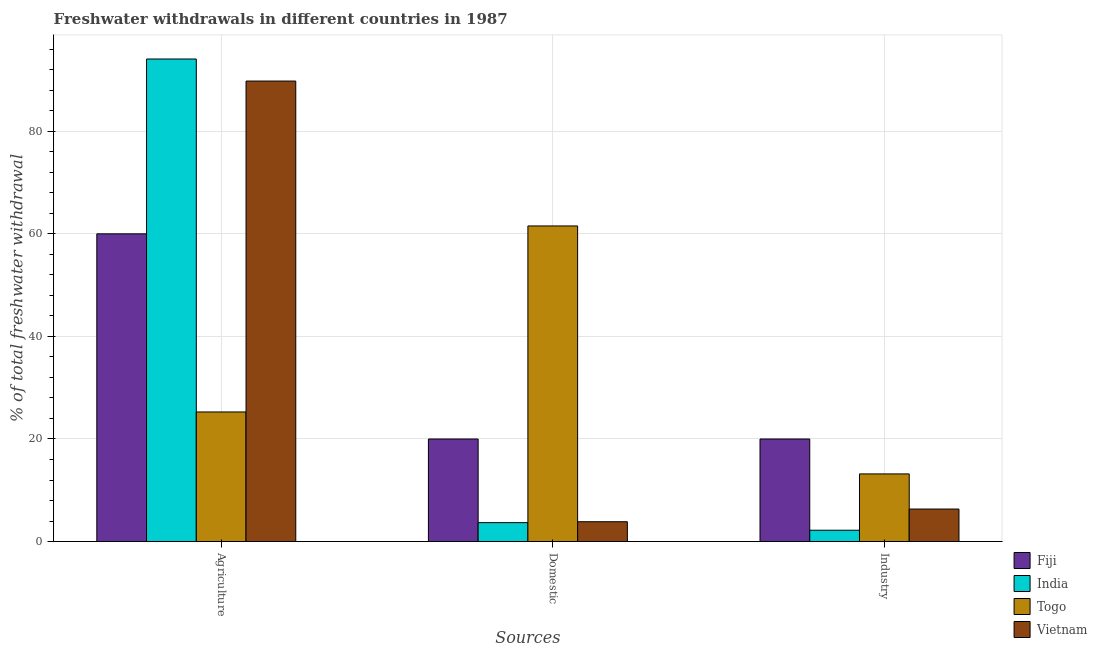How many different coloured bars are there?
Provide a short and direct response. 4. How many groups of bars are there?
Offer a very short reply. 3. How many bars are there on the 2nd tick from the left?
Provide a succinct answer. 4. What is the label of the 1st group of bars from the left?
Make the answer very short. Agriculture. What is the percentage of freshwater withdrawal for domestic purposes in Togo?
Offer a very short reply. 61.54. Across all countries, what is the minimum percentage of freshwater withdrawal for agriculture?
Your response must be concise. 25.27. In which country was the percentage of freshwater withdrawal for domestic purposes maximum?
Your answer should be compact. Togo. In which country was the percentage of freshwater withdrawal for industry minimum?
Offer a terse response. India. What is the total percentage of freshwater withdrawal for industry in the graph?
Offer a very short reply. 41.74. What is the difference between the percentage of freshwater withdrawal for industry in India and that in Fiji?
Provide a succinct answer. -17.79. What is the difference between the percentage of freshwater withdrawal for agriculture in Vietnam and the percentage of freshwater withdrawal for industry in Togo?
Offer a terse response. 76.6. What is the average percentage of freshwater withdrawal for industry per country?
Your answer should be very brief. 10.44. What is the difference between the percentage of freshwater withdrawal for agriculture and percentage of freshwater withdrawal for domestic purposes in Fiji?
Offer a terse response. 40. What is the ratio of the percentage of freshwater withdrawal for industry in Togo to that in Vietnam?
Give a very brief answer. 2.08. Is the difference between the percentage of freshwater withdrawal for agriculture in Vietnam and Fiji greater than the difference between the percentage of freshwater withdrawal for domestic purposes in Vietnam and Fiji?
Give a very brief answer. Yes. What is the difference between the highest and the second highest percentage of freshwater withdrawal for domestic purposes?
Give a very brief answer. 41.54. What is the difference between the highest and the lowest percentage of freshwater withdrawal for domestic purposes?
Your answer should be compact. 57.85. In how many countries, is the percentage of freshwater withdrawal for agriculture greater than the average percentage of freshwater withdrawal for agriculture taken over all countries?
Keep it short and to the point. 2. Is the sum of the percentage of freshwater withdrawal for industry in Togo and Fiji greater than the maximum percentage of freshwater withdrawal for domestic purposes across all countries?
Keep it short and to the point. No. What does the 1st bar from the left in Domestic represents?
Offer a terse response. Fiji. What does the 4th bar from the right in Domestic represents?
Keep it short and to the point. Fiji. How many countries are there in the graph?
Provide a short and direct response. 4. What is the difference between two consecutive major ticks on the Y-axis?
Keep it short and to the point. 20. Are the values on the major ticks of Y-axis written in scientific E-notation?
Ensure brevity in your answer.  No. Does the graph contain any zero values?
Provide a short and direct response. No. Does the graph contain grids?
Ensure brevity in your answer.  Yes. What is the title of the graph?
Ensure brevity in your answer.  Freshwater withdrawals in different countries in 1987. What is the label or title of the X-axis?
Provide a short and direct response. Sources. What is the label or title of the Y-axis?
Provide a short and direct response. % of total freshwater withdrawal. What is the % of total freshwater withdrawal of Fiji in Agriculture?
Your answer should be compact. 60. What is the % of total freshwater withdrawal of India in Agriculture?
Make the answer very short. 94.09. What is the % of total freshwater withdrawal in Togo in Agriculture?
Offer a terse response. 25.27. What is the % of total freshwater withdrawal of Vietnam in Agriculture?
Your response must be concise. 89.79. What is the % of total freshwater withdrawal in Fiji in Domestic?
Offer a very short reply. 20. What is the % of total freshwater withdrawal of India in Domestic?
Offer a very short reply. 3.69. What is the % of total freshwater withdrawal of Togo in Domestic?
Keep it short and to the point. 61.54. What is the % of total freshwater withdrawal of Vietnam in Domestic?
Offer a very short reply. 3.87. What is the % of total freshwater withdrawal in Fiji in Industry?
Make the answer very short. 20. What is the % of total freshwater withdrawal of India in Industry?
Ensure brevity in your answer.  2.21. What is the % of total freshwater withdrawal of Togo in Industry?
Your answer should be very brief. 13.19. What is the % of total freshwater withdrawal of Vietnam in Industry?
Provide a succinct answer. 6.34. Across all Sources, what is the maximum % of total freshwater withdrawal of India?
Ensure brevity in your answer.  94.09. Across all Sources, what is the maximum % of total freshwater withdrawal in Togo?
Offer a terse response. 61.54. Across all Sources, what is the maximum % of total freshwater withdrawal of Vietnam?
Provide a short and direct response. 89.79. Across all Sources, what is the minimum % of total freshwater withdrawal in India?
Give a very brief answer. 2.21. Across all Sources, what is the minimum % of total freshwater withdrawal in Togo?
Offer a very short reply. 13.19. Across all Sources, what is the minimum % of total freshwater withdrawal in Vietnam?
Your answer should be compact. 3.87. What is the total % of total freshwater withdrawal of India in the graph?
Give a very brief answer. 99.99. What is the total % of total freshwater withdrawal in Togo in the graph?
Make the answer very short. 100. What is the total % of total freshwater withdrawal of Vietnam in the graph?
Provide a short and direct response. 100. What is the difference between the % of total freshwater withdrawal of India in Agriculture and that in Domestic?
Offer a very short reply. 90.4. What is the difference between the % of total freshwater withdrawal in Togo in Agriculture and that in Domestic?
Provide a succinct answer. -36.27. What is the difference between the % of total freshwater withdrawal in Vietnam in Agriculture and that in Domestic?
Provide a short and direct response. 85.92. What is the difference between the % of total freshwater withdrawal in India in Agriculture and that in Industry?
Keep it short and to the point. 91.88. What is the difference between the % of total freshwater withdrawal in Togo in Agriculture and that in Industry?
Your answer should be very brief. 12.08. What is the difference between the % of total freshwater withdrawal in Vietnam in Agriculture and that in Industry?
Provide a short and direct response. 83.45. What is the difference between the % of total freshwater withdrawal of Fiji in Domestic and that in Industry?
Your answer should be very brief. 0. What is the difference between the % of total freshwater withdrawal in India in Domestic and that in Industry?
Offer a terse response. 1.48. What is the difference between the % of total freshwater withdrawal of Togo in Domestic and that in Industry?
Your answer should be compact. 48.35. What is the difference between the % of total freshwater withdrawal in Vietnam in Domestic and that in Industry?
Ensure brevity in your answer.  -2.47. What is the difference between the % of total freshwater withdrawal in Fiji in Agriculture and the % of total freshwater withdrawal in India in Domestic?
Make the answer very short. 56.31. What is the difference between the % of total freshwater withdrawal of Fiji in Agriculture and the % of total freshwater withdrawal of Togo in Domestic?
Your answer should be very brief. -1.54. What is the difference between the % of total freshwater withdrawal of Fiji in Agriculture and the % of total freshwater withdrawal of Vietnam in Domestic?
Offer a very short reply. 56.13. What is the difference between the % of total freshwater withdrawal of India in Agriculture and the % of total freshwater withdrawal of Togo in Domestic?
Give a very brief answer. 32.55. What is the difference between the % of total freshwater withdrawal in India in Agriculture and the % of total freshwater withdrawal in Vietnam in Domestic?
Keep it short and to the point. 90.22. What is the difference between the % of total freshwater withdrawal of Togo in Agriculture and the % of total freshwater withdrawal of Vietnam in Domestic?
Provide a short and direct response. 21.4. What is the difference between the % of total freshwater withdrawal in Fiji in Agriculture and the % of total freshwater withdrawal in India in Industry?
Make the answer very short. 57.79. What is the difference between the % of total freshwater withdrawal of Fiji in Agriculture and the % of total freshwater withdrawal of Togo in Industry?
Offer a very short reply. 46.81. What is the difference between the % of total freshwater withdrawal of Fiji in Agriculture and the % of total freshwater withdrawal of Vietnam in Industry?
Offer a very short reply. 53.66. What is the difference between the % of total freshwater withdrawal in India in Agriculture and the % of total freshwater withdrawal in Togo in Industry?
Keep it short and to the point. 80.9. What is the difference between the % of total freshwater withdrawal in India in Agriculture and the % of total freshwater withdrawal in Vietnam in Industry?
Ensure brevity in your answer.  87.75. What is the difference between the % of total freshwater withdrawal in Togo in Agriculture and the % of total freshwater withdrawal in Vietnam in Industry?
Your answer should be compact. 18.93. What is the difference between the % of total freshwater withdrawal in Fiji in Domestic and the % of total freshwater withdrawal in India in Industry?
Offer a terse response. 17.79. What is the difference between the % of total freshwater withdrawal in Fiji in Domestic and the % of total freshwater withdrawal in Togo in Industry?
Your answer should be compact. 6.81. What is the difference between the % of total freshwater withdrawal in Fiji in Domestic and the % of total freshwater withdrawal in Vietnam in Industry?
Offer a very short reply. 13.66. What is the difference between the % of total freshwater withdrawal in India in Domestic and the % of total freshwater withdrawal in Togo in Industry?
Your answer should be very brief. -9.5. What is the difference between the % of total freshwater withdrawal of India in Domestic and the % of total freshwater withdrawal of Vietnam in Industry?
Your answer should be very brief. -2.65. What is the difference between the % of total freshwater withdrawal in Togo in Domestic and the % of total freshwater withdrawal in Vietnam in Industry?
Your answer should be compact. 55.2. What is the average % of total freshwater withdrawal in Fiji per Sources?
Provide a succinct answer. 33.33. What is the average % of total freshwater withdrawal in India per Sources?
Offer a very short reply. 33.33. What is the average % of total freshwater withdrawal in Togo per Sources?
Ensure brevity in your answer.  33.33. What is the average % of total freshwater withdrawal of Vietnam per Sources?
Offer a very short reply. 33.33. What is the difference between the % of total freshwater withdrawal in Fiji and % of total freshwater withdrawal in India in Agriculture?
Give a very brief answer. -34.09. What is the difference between the % of total freshwater withdrawal of Fiji and % of total freshwater withdrawal of Togo in Agriculture?
Your response must be concise. 34.73. What is the difference between the % of total freshwater withdrawal of Fiji and % of total freshwater withdrawal of Vietnam in Agriculture?
Make the answer very short. -29.79. What is the difference between the % of total freshwater withdrawal in India and % of total freshwater withdrawal in Togo in Agriculture?
Your response must be concise. 68.82. What is the difference between the % of total freshwater withdrawal in India and % of total freshwater withdrawal in Vietnam in Agriculture?
Give a very brief answer. 4.3. What is the difference between the % of total freshwater withdrawal of Togo and % of total freshwater withdrawal of Vietnam in Agriculture?
Provide a short and direct response. -64.52. What is the difference between the % of total freshwater withdrawal in Fiji and % of total freshwater withdrawal in India in Domestic?
Offer a terse response. 16.31. What is the difference between the % of total freshwater withdrawal in Fiji and % of total freshwater withdrawal in Togo in Domestic?
Make the answer very short. -41.54. What is the difference between the % of total freshwater withdrawal of Fiji and % of total freshwater withdrawal of Vietnam in Domestic?
Your answer should be compact. 16.13. What is the difference between the % of total freshwater withdrawal of India and % of total freshwater withdrawal of Togo in Domestic?
Offer a very short reply. -57.85. What is the difference between the % of total freshwater withdrawal of India and % of total freshwater withdrawal of Vietnam in Domestic?
Keep it short and to the point. -0.17. What is the difference between the % of total freshwater withdrawal in Togo and % of total freshwater withdrawal in Vietnam in Domestic?
Offer a very short reply. 57.67. What is the difference between the % of total freshwater withdrawal of Fiji and % of total freshwater withdrawal of India in Industry?
Offer a terse response. 17.79. What is the difference between the % of total freshwater withdrawal of Fiji and % of total freshwater withdrawal of Togo in Industry?
Ensure brevity in your answer.  6.81. What is the difference between the % of total freshwater withdrawal of Fiji and % of total freshwater withdrawal of Vietnam in Industry?
Make the answer very short. 13.66. What is the difference between the % of total freshwater withdrawal in India and % of total freshwater withdrawal in Togo in Industry?
Offer a terse response. -10.98. What is the difference between the % of total freshwater withdrawal of India and % of total freshwater withdrawal of Vietnam in Industry?
Your response must be concise. -4.13. What is the difference between the % of total freshwater withdrawal of Togo and % of total freshwater withdrawal of Vietnam in Industry?
Provide a succinct answer. 6.85. What is the ratio of the % of total freshwater withdrawal of India in Agriculture to that in Domestic?
Your answer should be very brief. 25.49. What is the ratio of the % of total freshwater withdrawal in Togo in Agriculture to that in Domestic?
Provide a short and direct response. 0.41. What is the ratio of the % of total freshwater withdrawal in Vietnam in Agriculture to that in Domestic?
Your answer should be very brief. 23.23. What is the ratio of the % of total freshwater withdrawal of Fiji in Agriculture to that in Industry?
Offer a terse response. 3. What is the ratio of the % of total freshwater withdrawal in India in Agriculture to that in Industry?
Your answer should be compact. 42.56. What is the ratio of the % of total freshwater withdrawal in Togo in Agriculture to that in Industry?
Make the answer very short. 1.92. What is the ratio of the % of total freshwater withdrawal of Vietnam in Agriculture to that in Industry?
Offer a terse response. 14.16. What is the ratio of the % of total freshwater withdrawal in Fiji in Domestic to that in Industry?
Ensure brevity in your answer.  1. What is the ratio of the % of total freshwater withdrawal of India in Domestic to that in Industry?
Provide a succinct answer. 1.67. What is the ratio of the % of total freshwater withdrawal of Togo in Domestic to that in Industry?
Provide a succinct answer. 4.67. What is the ratio of the % of total freshwater withdrawal in Vietnam in Domestic to that in Industry?
Make the answer very short. 0.61. What is the difference between the highest and the second highest % of total freshwater withdrawal of India?
Your answer should be very brief. 90.4. What is the difference between the highest and the second highest % of total freshwater withdrawal of Togo?
Ensure brevity in your answer.  36.27. What is the difference between the highest and the second highest % of total freshwater withdrawal in Vietnam?
Ensure brevity in your answer.  83.45. What is the difference between the highest and the lowest % of total freshwater withdrawal of Fiji?
Ensure brevity in your answer.  40. What is the difference between the highest and the lowest % of total freshwater withdrawal in India?
Provide a succinct answer. 91.88. What is the difference between the highest and the lowest % of total freshwater withdrawal of Togo?
Offer a very short reply. 48.35. What is the difference between the highest and the lowest % of total freshwater withdrawal of Vietnam?
Ensure brevity in your answer.  85.92. 